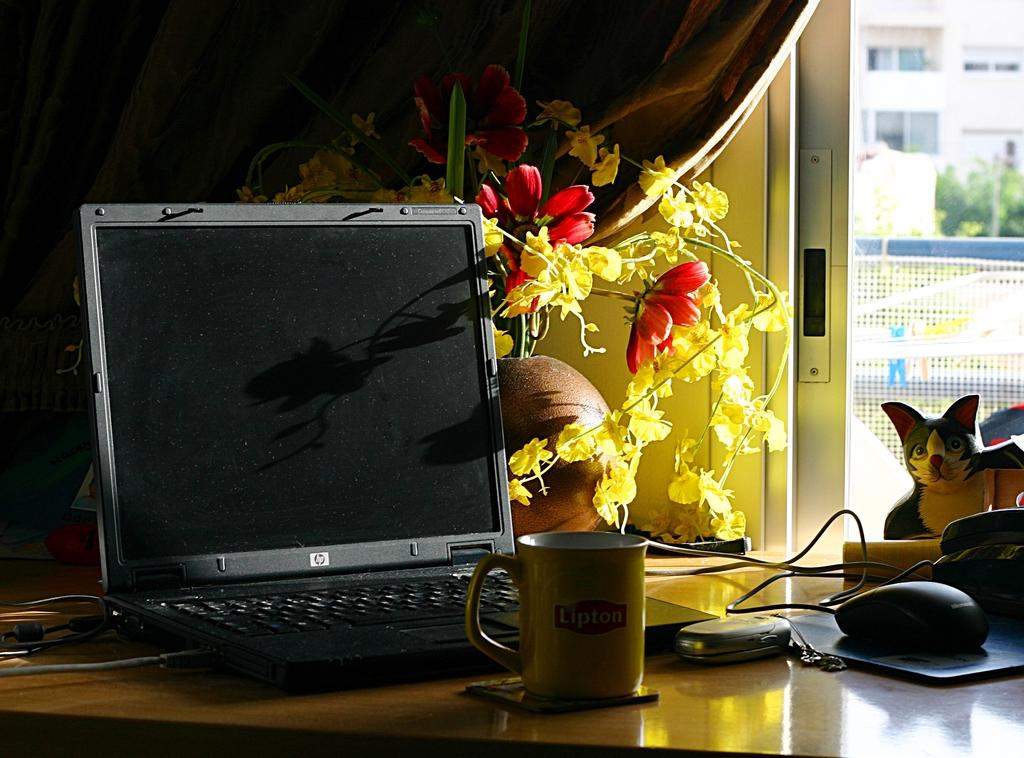What electronic device is on the table in the image? There is a laptop on the table in the image. What type of beverage container is on the table? There is a cup on the table. What other communication device is on the table? There is a mobile on the table. What device is used for input on the laptop? There is a mouse on the table, which is used for input on the laptop. What surface is the mouse placed on? There is a mouse pad on the table for the mouse to be used on. What non-electronic items are on the table? There are toys on the table. What decorative item is on the table? There is a flower vase on the table. What architectural feature is visible in the background? There is a building in the background. What type of vegetation is visible in the background? There are trees in the background. What stage of development is the stem in the image? There is no stem present in the image. What type of toothpaste is visible in the image? There is no toothpaste present in the image. 